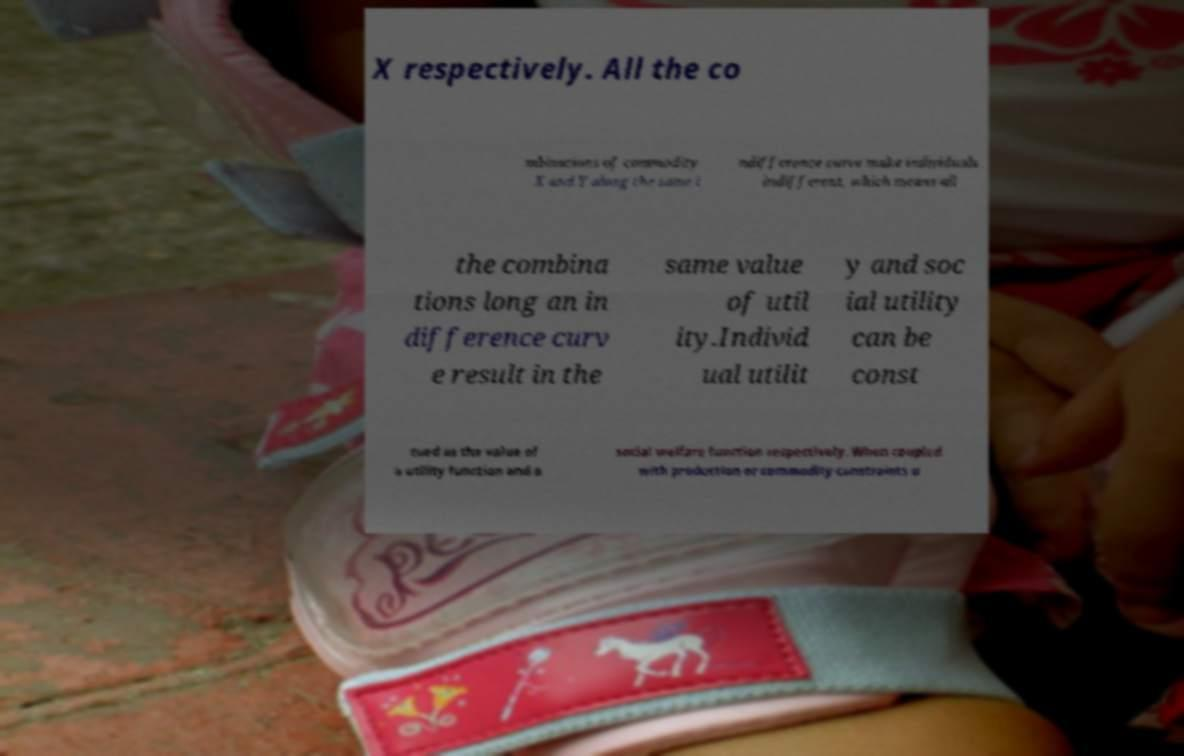Can you read and provide the text displayed in the image?This photo seems to have some interesting text. Can you extract and type it out for me? X respectively. All the co mbinations of commodity X and Y along the same i ndifference curve make individuals indifferent, which means all the combina tions long an in difference curv e result in the same value of util ity.Individ ual utilit y and soc ial utility can be const rued as the value of a utility function and a social welfare function respectively. When coupled with production or commodity constraints u 